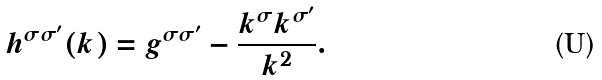Convert formula to latex. <formula><loc_0><loc_0><loc_500><loc_500>h ^ { \sigma \sigma ^ { \prime } } ( k ) = g ^ { \sigma \sigma ^ { \prime } } - \frac { k ^ { \sigma } k ^ { \sigma ^ { \prime } } } { k ^ { 2 } } .</formula> 